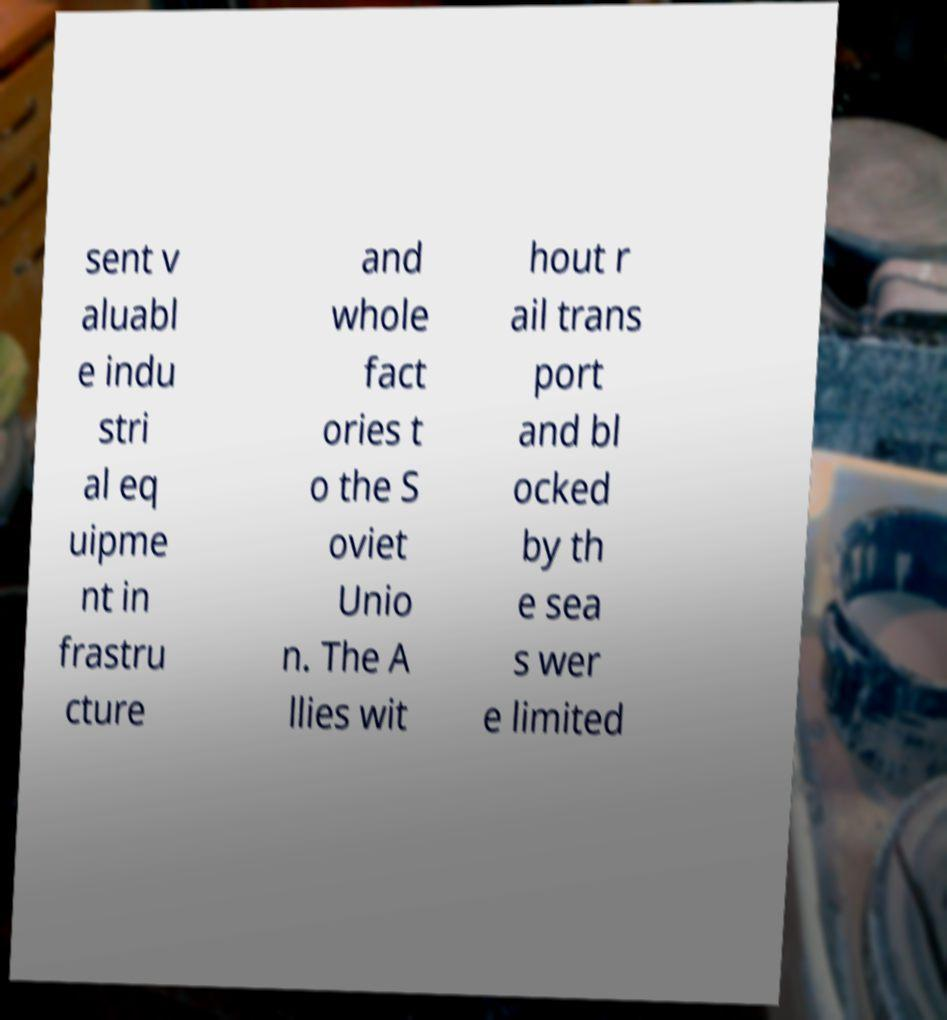Please read and relay the text visible in this image. What does it say? sent v aluabl e indu stri al eq uipme nt in frastru cture and whole fact ories t o the S oviet Unio n. The A llies wit hout r ail trans port and bl ocked by th e sea s wer e limited 